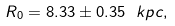Convert formula to latex. <formula><loc_0><loc_0><loc_500><loc_500>R _ { 0 } = 8 . 3 3 \pm 0 . 3 5 \ k p c ,</formula> 